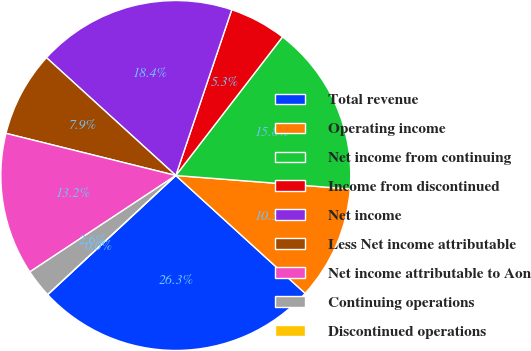Convert chart to OTSL. <chart><loc_0><loc_0><loc_500><loc_500><pie_chart><fcel>Total revenue<fcel>Operating income<fcel>Net income from continuing<fcel>Income from discontinued<fcel>Net income<fcel>Less Net income attributable<fcel>Net income attributable to Aon<fcel>Continuing operations<fcel>Discontinued operations<nl><fcel>26.32%<fcel>10.53%<fcel>15.79%<fcel>5.26%<fcel>18.42%<fcel>7.89%<fcel>13.16%<fcel>2.63%<fcel>0.0%<nl></chart> 